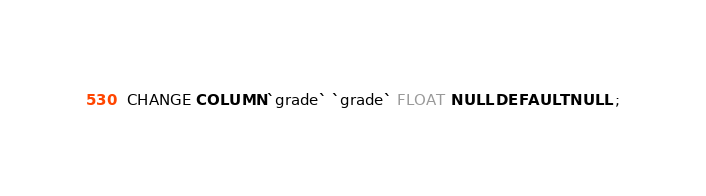Convert code to text. <code><loc_0><loc_0><loc_500><loc_500><_SQL_>CHANGE COLUMN `grade` `grade` FLOAT NULL DEFAULT NULL ;
</code> 